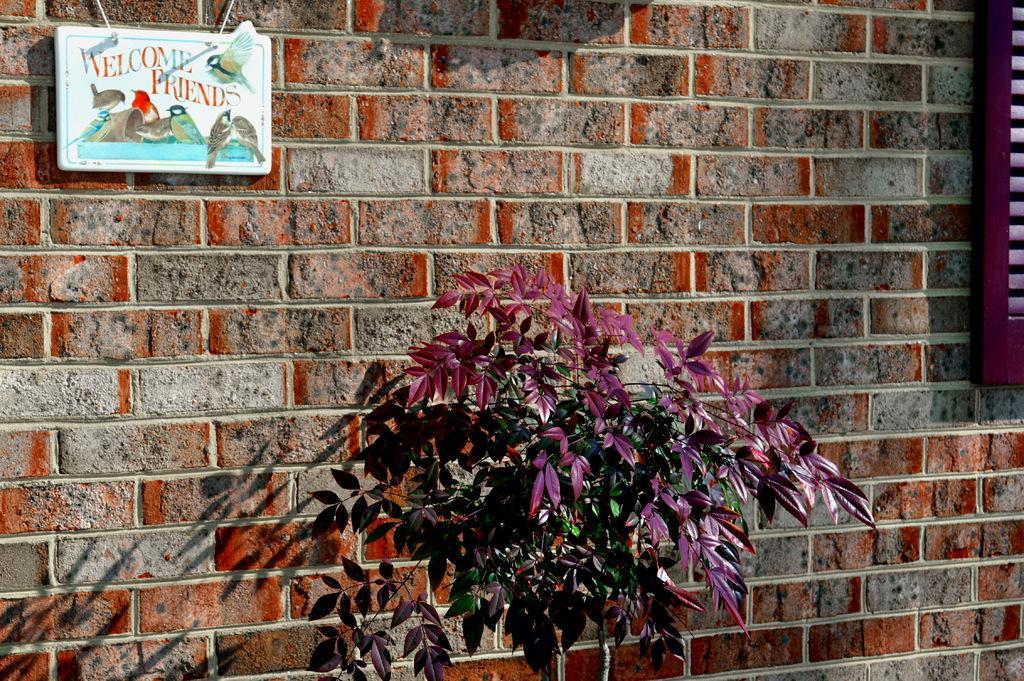How would you summarize this image in a sentence or two? In this picture there are boards on the wall and there is text on the board and there is a plant in the foreground and there is a shadow of the plant on the wall. 